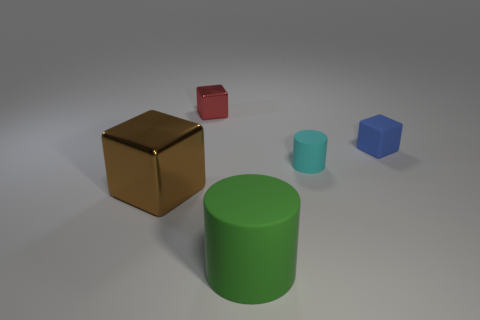Subtract all tiny metallic cubes. How many cubes are left? 2 Add 3 shiny balls. How many objects exist? 8 Subtract 1 blocks. How many blocks are left? 2 Subtract all cylinders. How many objects are left? 3 Add 5 cyan rubber cylinders. How many cyan rubber cylinders are left? 6 Add 2 big cubes. How many big cubes exist? 3 Subtract 1 brown blocks. How many objects are left? 4 Subtract all purple blocks. Subtract all cyan spheres. How many blocks are left? 3 Subtract all spheres. Subtract all matte things. How many objects are left? 2 